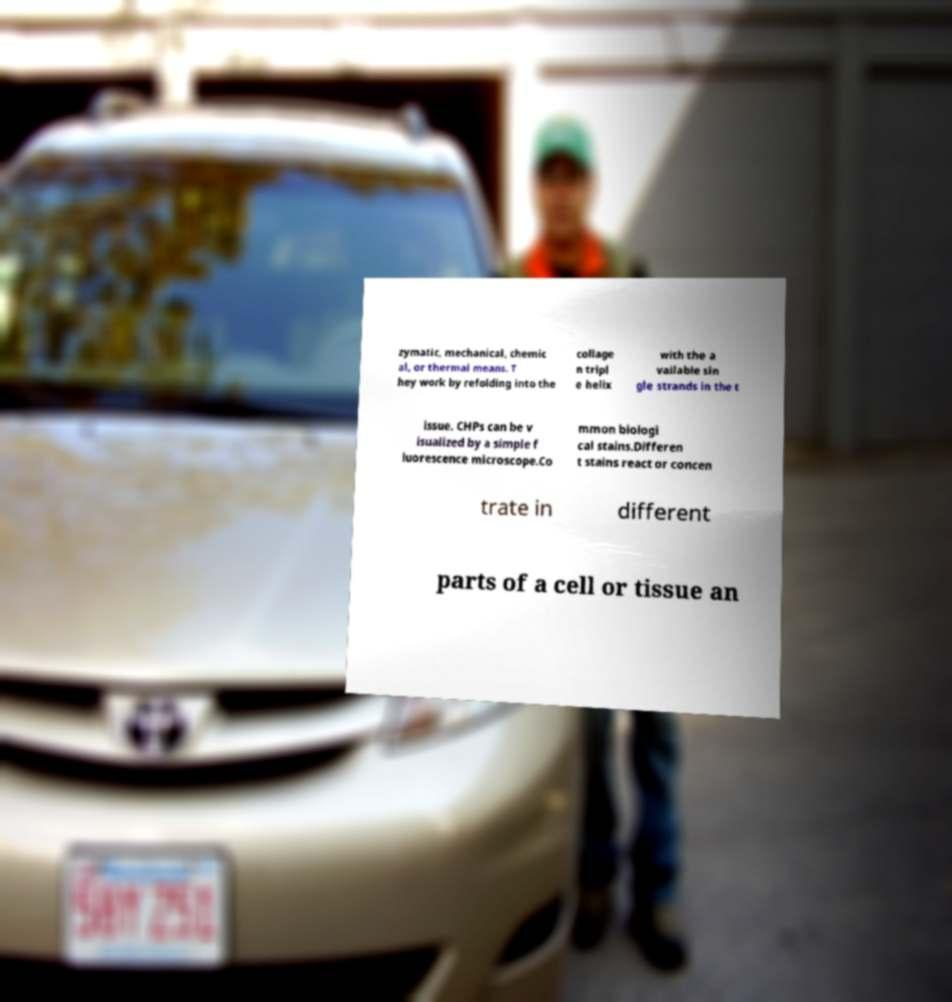Can you read and provide the text displayed in the image?This photo seems to have some interesting text. Can you extract and type it out for me? zymatic, mechanical, chemic al, or thermal means. T hey work by refolding into the collage n tripl e helix with the a vailable sin gle strands in the t issue. CHPs can be v isualized by a simple f luorescence microscope.Co mmon biologi cal stains.Differen t stains react or concen trate in different parts of a cell or tissue an 